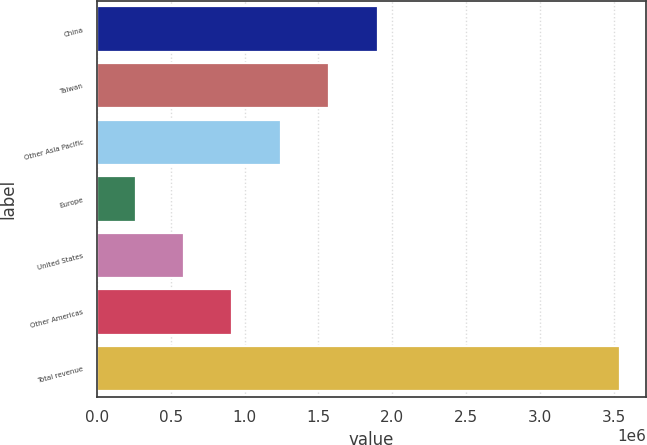Convert chart to OTSL. <chart><loc_0><loc_0><loc_500><loc_500><bar_chart><fcel>China<fcel>Taiwan<fcel>Other Asia Pacific<fcel>Europe<fcel>United States<fcel>Other Americas<fcel>Total revenue<nl><fcel>1.90236e+06<fcel>1.57418e+06<fcel>1.24599e+06<fcel>261421<fcel>589610<fcel>917799<fcel>3.54331e+06<nl></chart> 